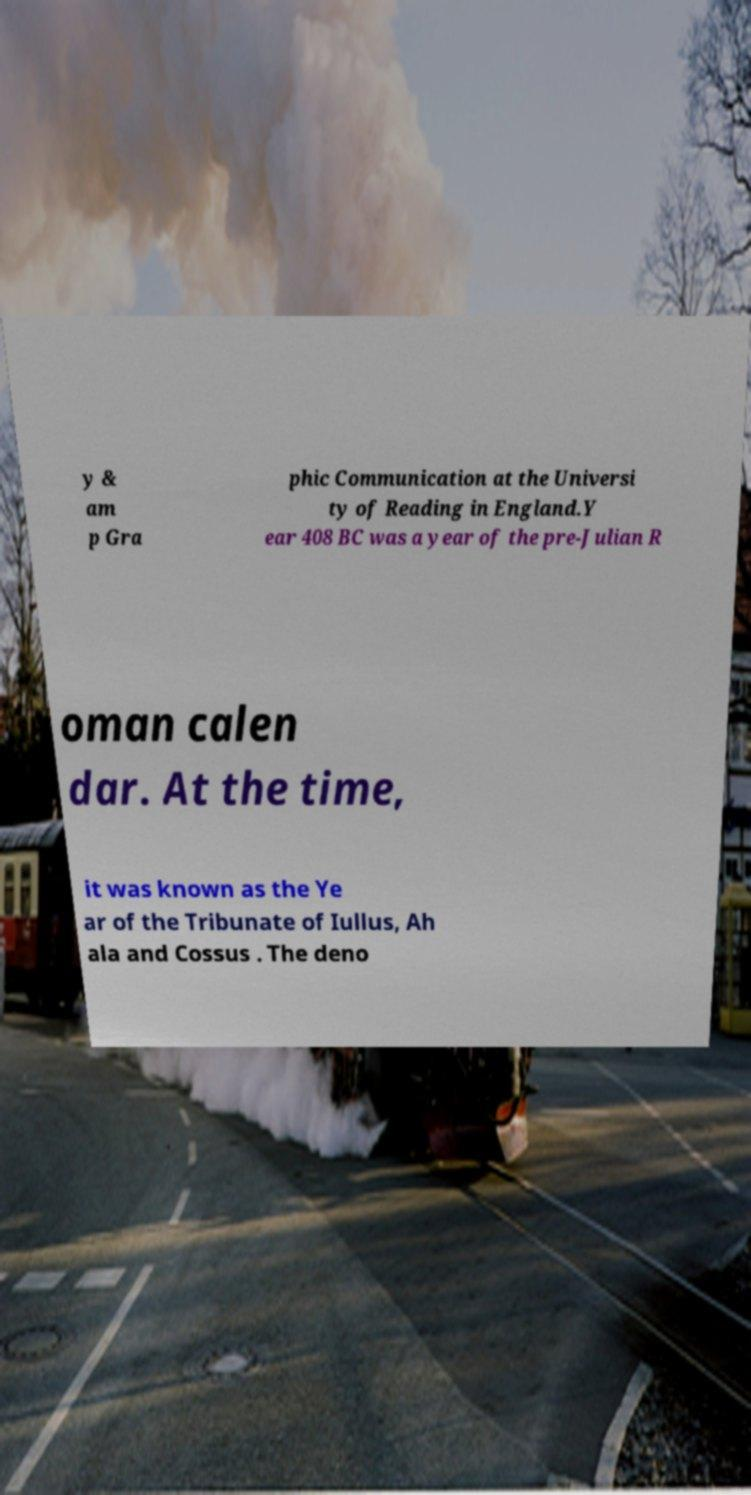What messages or text are displayed in this image? I need them in a readable, typed format. y & am p Gra phic Communication at the Universi ty of Reading in England.Y ear 408 BC was a year of the pre-Julian R oman calen dar. At the time, it was known as the Ye ar of the Tribunate of Iullus, Ah ala and Cossus . The deno 